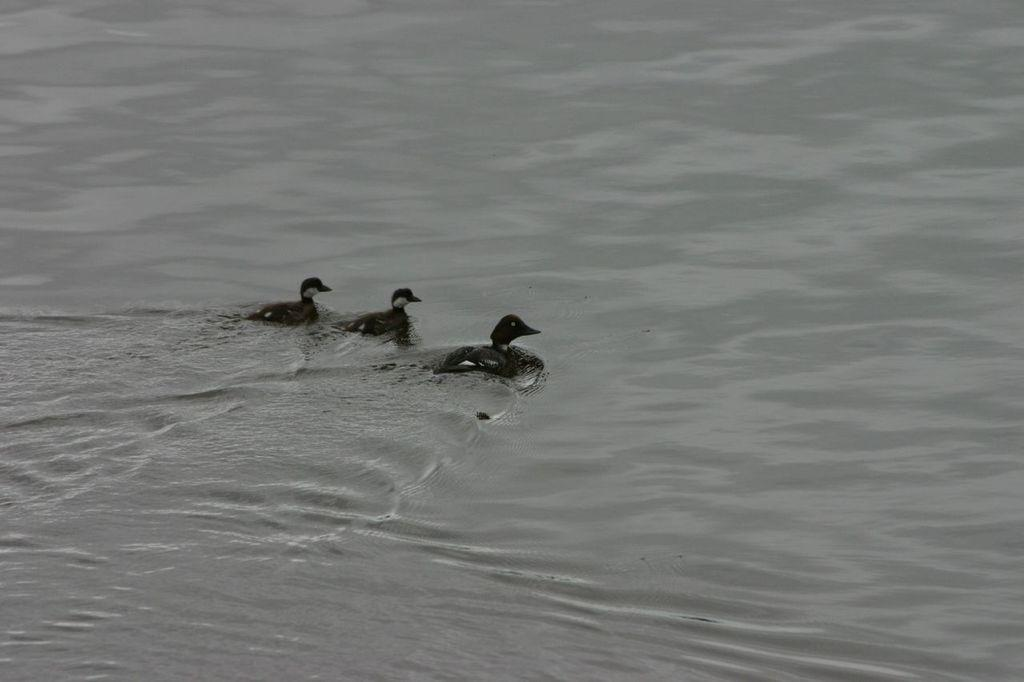How many ducks are present in the image? There are three ducks in the image. What are the ducks doing in the image? The ducks are swimming in water. Can you describe the water in the image? The water has ripples on it. What type of store can be seen in the background of the image? There is no store present in the image; it features three ducks swimming in water with ripples. 